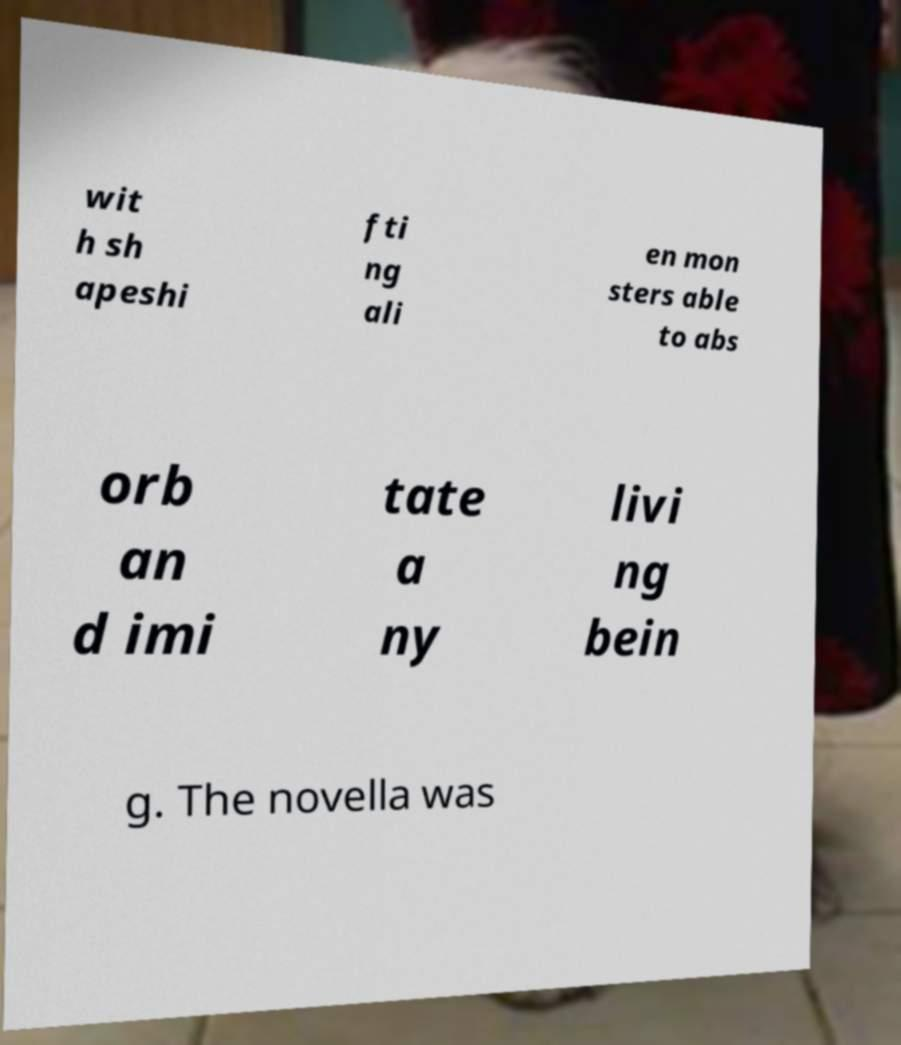Please identify and transcribe the text found in this image. wit h sh apeshi fti ng ali en mon sters able to abs orb an d imi tate a ny livi ng bein g. The novella was 